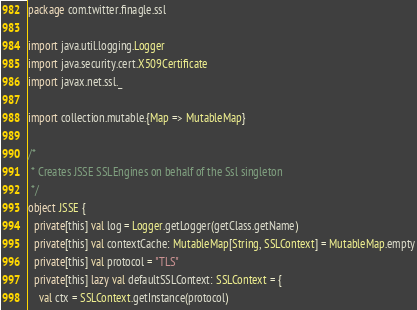Convert code to text. <code><loc_0><loc_0><loc_500><loc_500><_Scala_>package com.twitter.finagle.ssl

import java.util.logging.Logger
import java.security.cert.X509Certificate
import javax.net.ssl._

import collection.mutable.{Map => MutableMap}

/*
 * Creates JSSE SSLEngines on behalf of the Ssl singleton
 */
object JSSE {
  private[this] val log = Logger.getLogger(getClass.getName)
  private[this] val contextCache: MutableMap[String, SSLContext] = MutableMap.empty
  private[this] val protocol = "TLS"
  private[this] lazy val defaultSSLContext: SSLContext = {
    val ctx = SSLContext.getInstance(protocol)</code> 